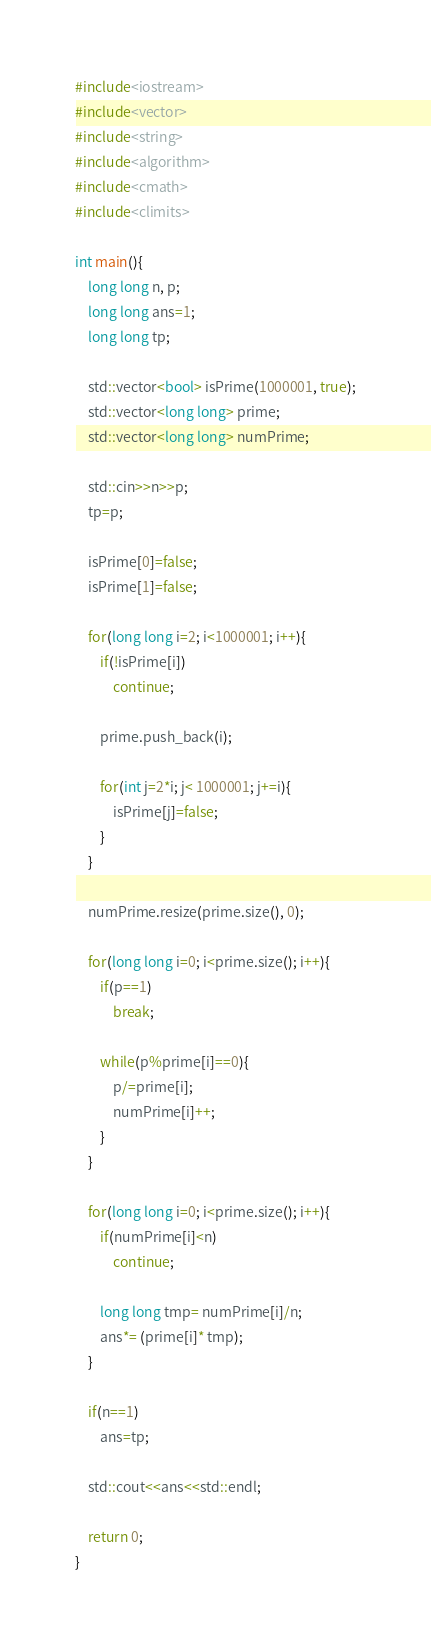Convert code to text. <code><loc_0><loc_0><loc_500><loc_500><_C++_>#include<iostream>
#include<vector>
#include<string>
#include<algorithm>
#include<cmath>
#include<climits>

int main(){
	long long n, p;
	long long ans=1;
	long long tp;

	std::vector<bool> isPrime(1000001, true);
	std::vector<long long> prime;
	std::vector<long long> numPrime;

	std::cin>>n>>p;
	tp=p;

	isPrime[0]=false;
	isPrime[1]=false;

	for(long long i=2; i<1000001; i++){
		if(!isPrime[i])
			continue;

		prime.push_back(i);

		for(int j=2*i; j< 1000001; j+=i){
			isPrime[j]=false;
		}
	}

	numPrime.resize(prime.size(), 0);

	for(long long i=0; i<prime.size(); i++){
		if(p==1)
			break;

		while(p%prime[i]==0){
			p/=prime[i];
			numPrime[i]++;
		}
	}
	
	for(long long i=0; i<prime.size(); i++){
		if(numPrime[i]<n)
			continue;

		long long tmp= numPrime[i]/n;
		ans*= (prime[i]* tmp);		
	}

	if(n==1)
		ans=tp;

	std::cout<<ans<<std::endl;

	return 0;
}</code> 